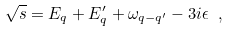<formula> <loc_0><loc_0><loc_500><loc_500>\sqrt { s } = E _ { q } + E _ { q } ^ { \prime } + \omega _ { q - q ^ { \prime } } - 3 i \epsilon \ ,</formula> 